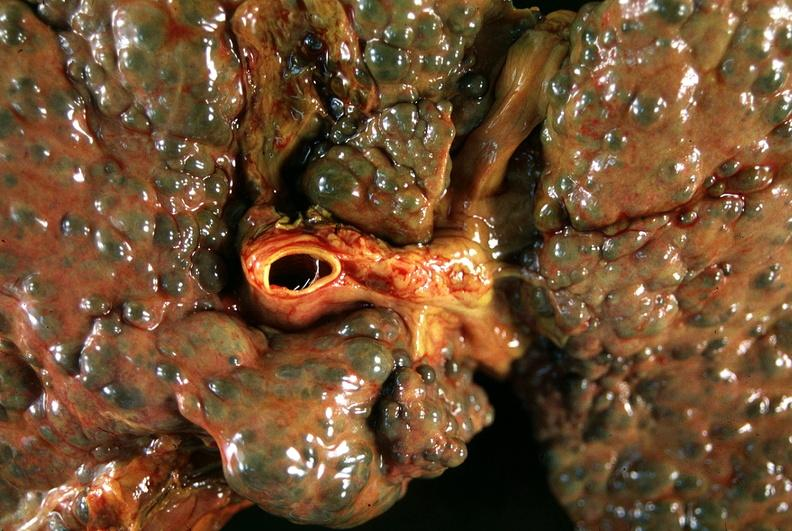does this image show liver, macronodular cirrhosis, hcv - transjugular intrahepatic portocaval shunt tips?
Answer the question using a single word or phrase. Yes 